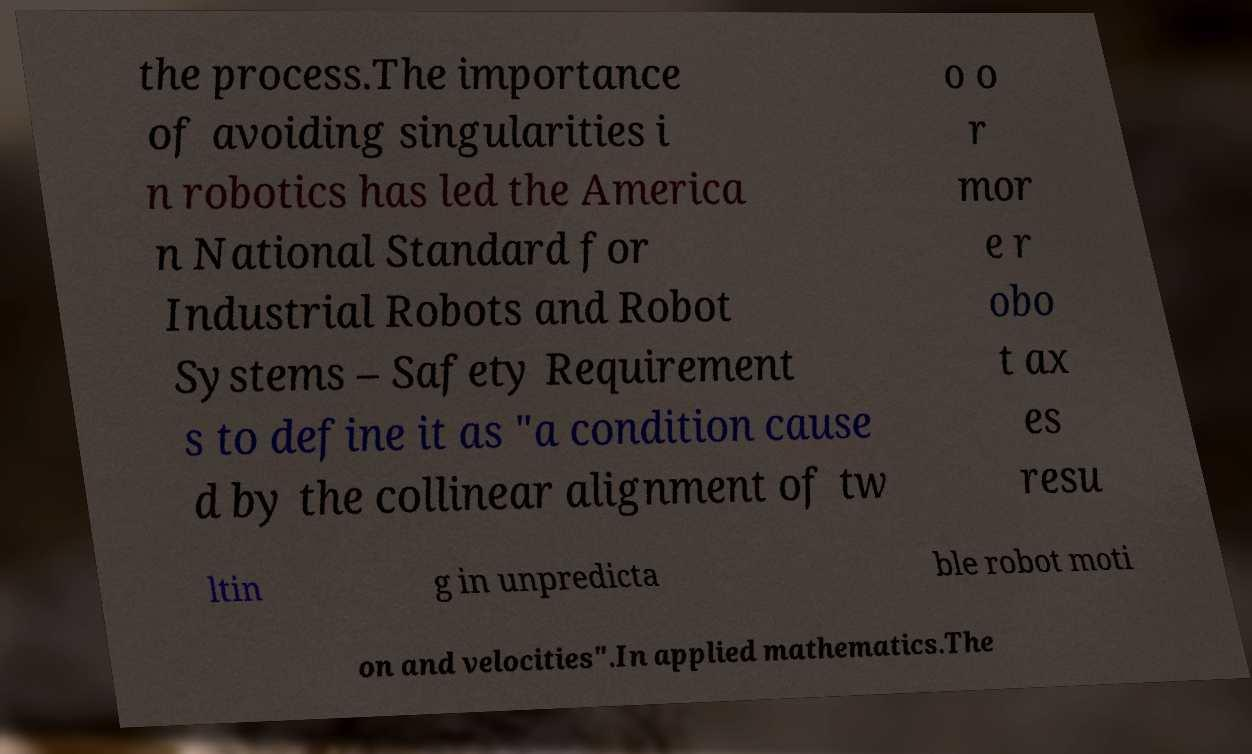Can you accurately transcribe the text from the provided image for me? the process.The importance of avoiding singularities i n robotics has led the America n National Standard for Industrial Robots and Robot Systems – Safety Requirement s to define it as "a condition cause d by the collinear alignment of tw o o r mor e r obo t ax es resu ltin g in unpredicta ble robot moti on and velocities".In applied mathematics.The 